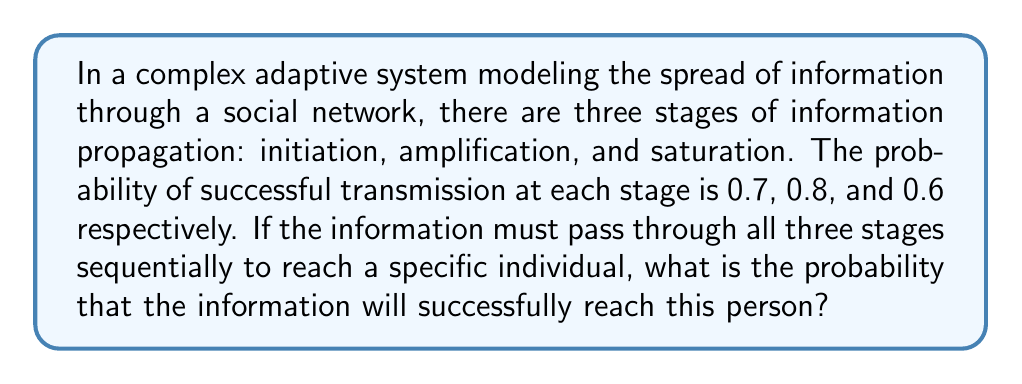Could you help me with this problem? To solve this problem, we need to consider the multi-step process of information propagation through the complex adaptive system. Let's break it down step-by-step:

1) We have three independent stages, each with its own probability of success:
   - Initiation: $p_1 = 0.7$
   - Amplification: $p_2 = 0.8$
   - Saturation: $p_3 = 0.6$

2) For the information to successfully reach the specific individual, it must pass through all three stages sequentially. This means we need all three events to occur.

3) When we have multiple independent events that all need to occur, we multiply their individual probabilities. This is known as the multiplication rule of probability.

4) Therefore, the probability of successful information transmission through all three stages is:

   $$P(\text{success}) = p_1 \times p_2 \times p_3$$

5) Substituting the given probabilities:

   $$P(\text{success}) = 0.7 \times 0.8 \times 0.6$$

6) Calculating:

   $$P(\text{success}) = 0.336$$

Thus, the probability that the information will successfully reach the specific individual is 0.336 or 33.6%.
Answer: $0.336$ 